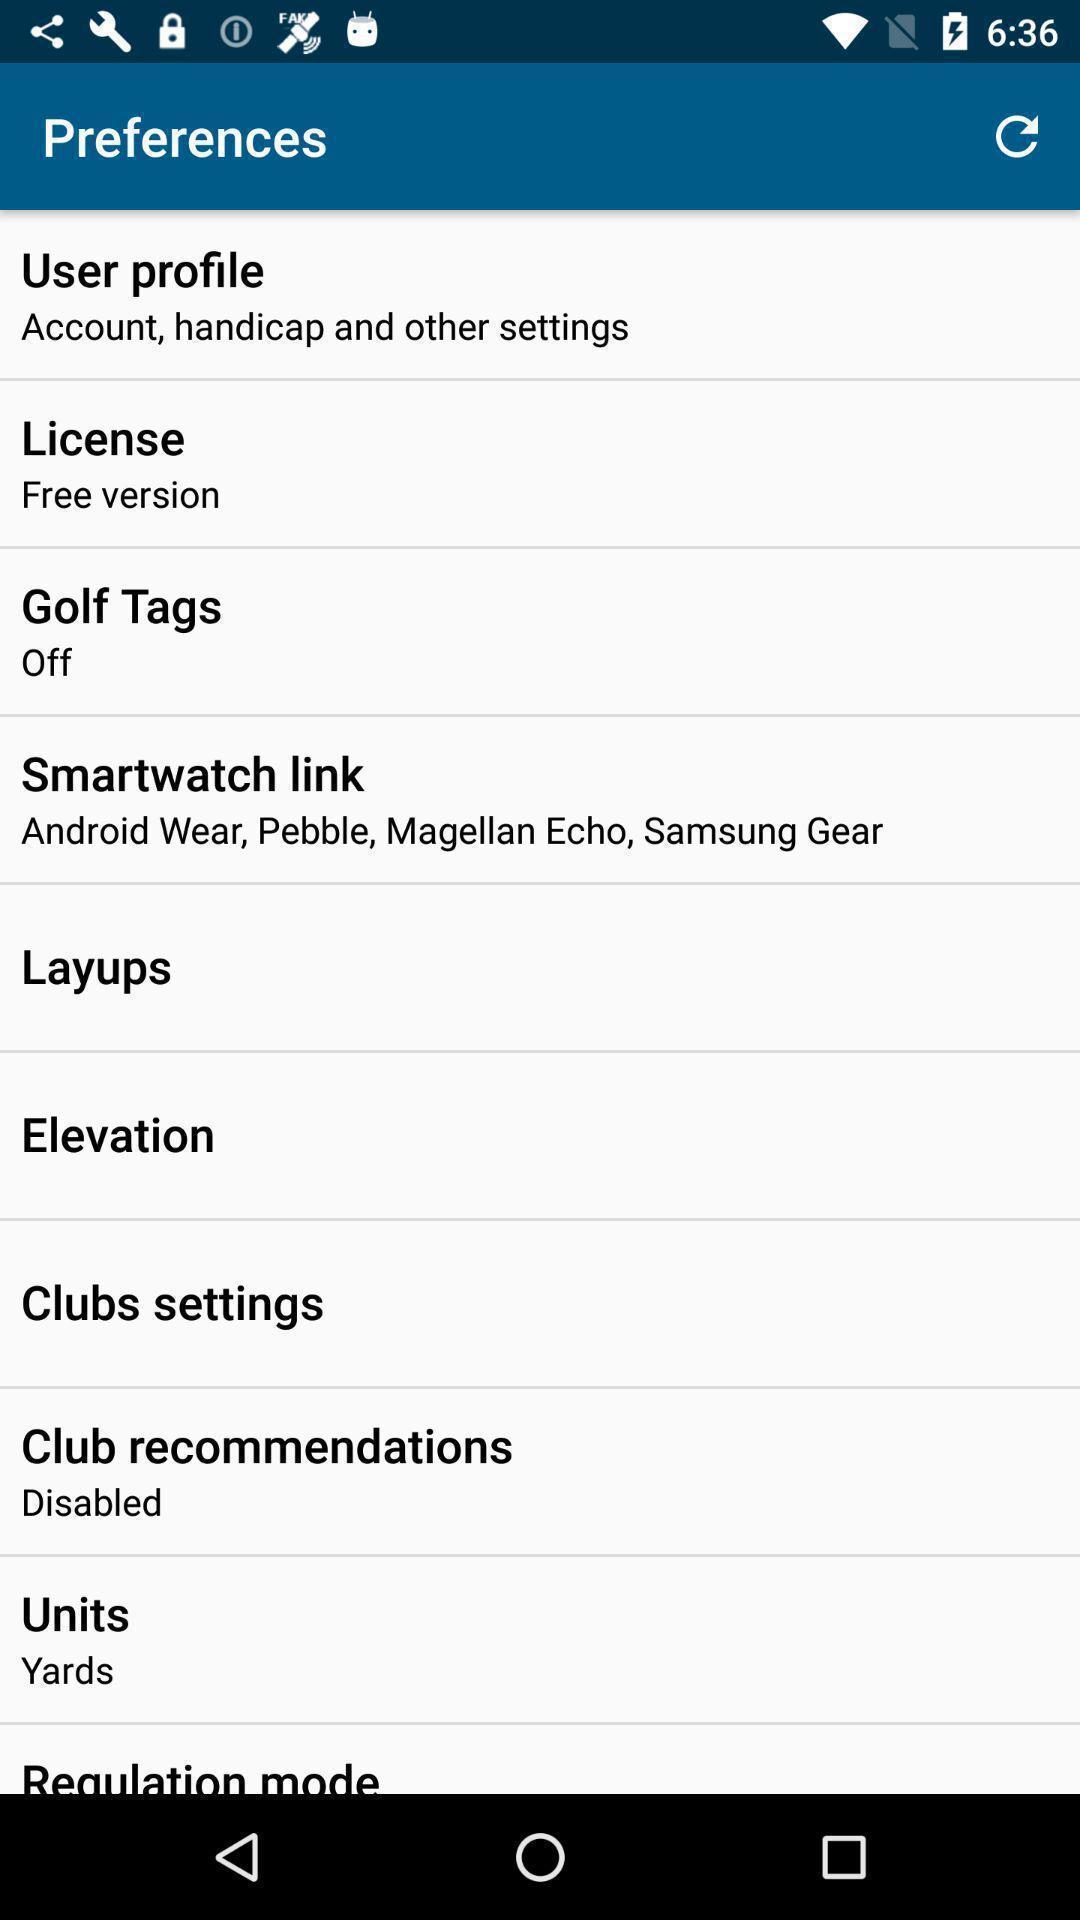Summarize the information in this screenshot. Various preferences page displayed. 